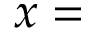<formula> <loc_0><loc_0><loc_500><loc_500>x =</formula> 